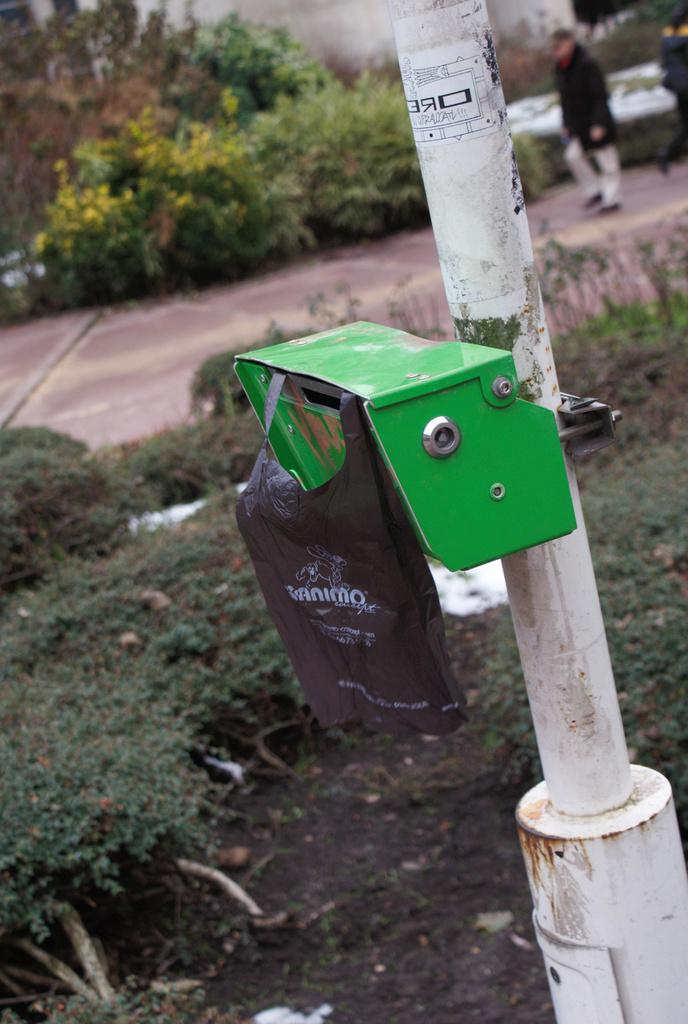What is the main object in the center of the image? There is a box in the center of the image. What else can be seen attached to a pole in the image? There is a bag attached to a pole in the image. What type of natural elements are visible in the background of the image? There are trees and plants in the background of the image. What is happening in the background of the image involving people? There are people walking on the road in the background of the image. How many stamps are visible on the box in the image? There are no stamps visible on the box in the image. What type of horses can be seen grazing in the background of the image? There are no horses present in the image; it features trees, plants, and people walking on the road. 